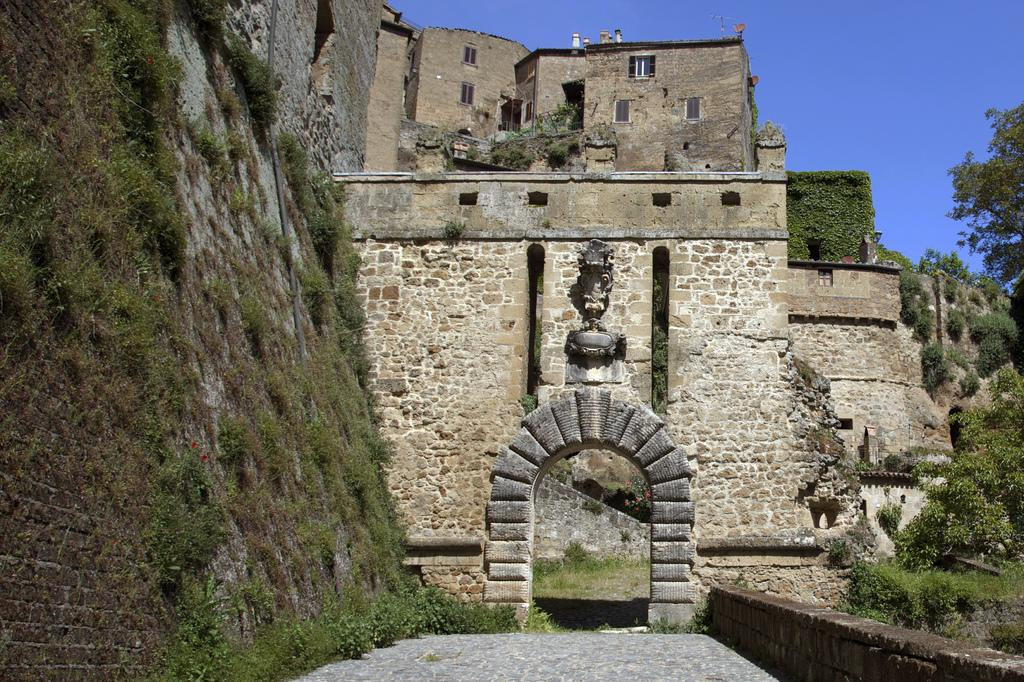What structure is located in the middle of the image? There is an arch in the middle of the image. What can be seen in the background of the image? There is a fort in the background of the image. What type of vegetation is on the right side of the image? There are trees on the right side of the image. What is visible at the top of the image? The sky is visible at the top of the image. Can you see a mark on the arch in the image? There is no mention of a mark on the arch in the provided facts, so we cannot determine if one is present. Is there a crown on top of the fort in the image? There is no mention of a crown on the fort in the provided facts, so we cannot determine if one is present. 